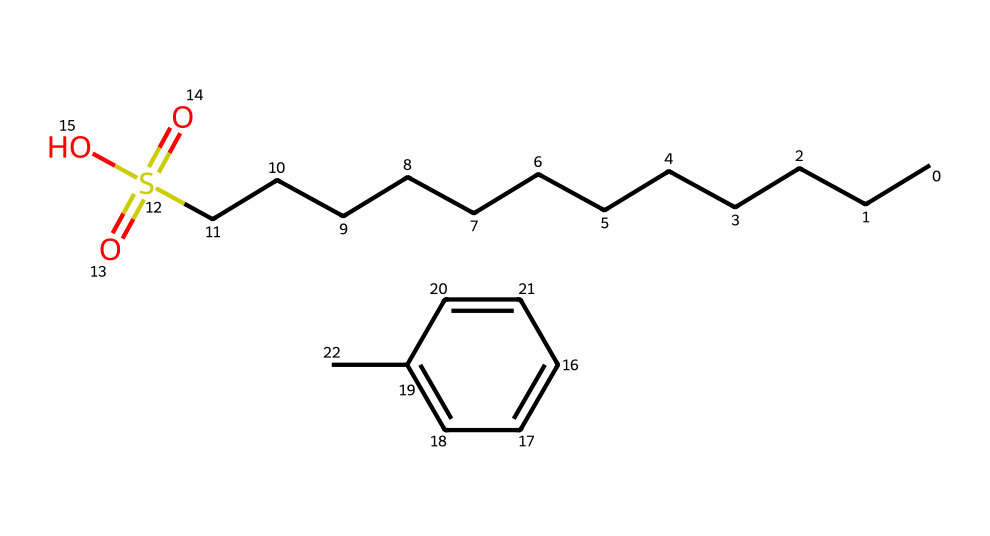What is the total number of carbon atoms in this chemical? By counting the carbon atoms in the alkyl chain (12 from CCCCCCCCCCCC) and the aromatic ring (6 from C1=CC=C(C=C1)), we find a total of 12 + 6 = 18 carbon atoms.
Answer: 18 What functional group is present in this molecule? The presence of the sulfonate group (-SO3H) attached to the alkyl benzene indicates that this molecule contains a sulfonic acid functional group.
Answer: sulfonic acid What type of detergent does this chemical represent? As it is an alkyl benzene sulfonate, which is a common class of synthetic detergents, it is classified specifically as an anionic detergent.
Answer: anionic detergent How many hydrogen atoms are present in the chemical? The total number of hydrogen atoms can be calculated by considering the hydrogens present on the alkyl chain and the aromatic ring, leading to a total of 30 hydrogen atoms.
Answer: 30 What is the role of the benzene ring in this chemical? The benzene ring increases the hydrophobic character of the molecule, enhancing its ability to dissolve non-polar substances, which is crucial for the detergent's cleaning efficiency.
Answer: hydrophobic character What is the significance of the sulfonate group in detergents? The sulfonate group contributes to the water-solubility of the detergent, allowing it to mix with water and effectively remove dirt and grease.
Answer: water-solubility How does this chemical behave in water? This chemical, being a surfactant, reduces the surface tension of water and helps form micelles that encapsulate grease and dirt, making them easier to wash away.
Answer: surfactant 